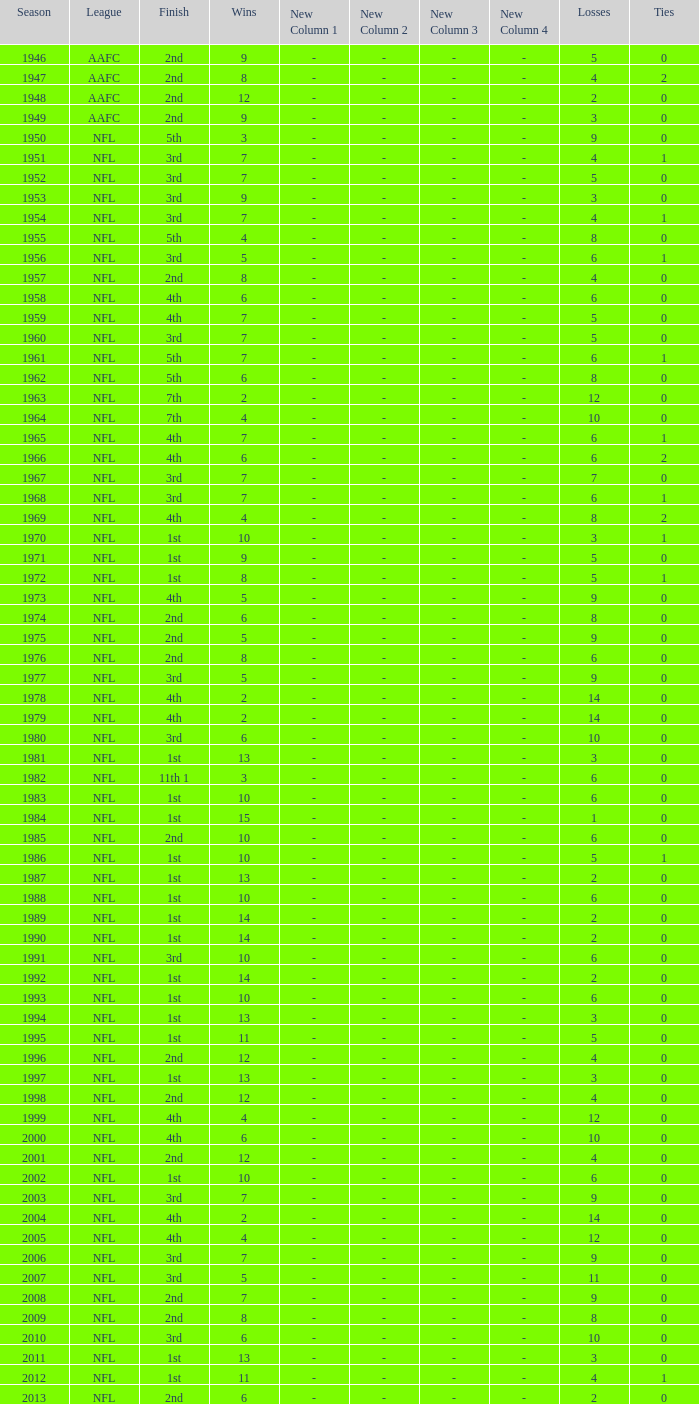In the nfl, what is the highest number of wins achieved by a team that finished in 1st place and had over 6 losses? None. 